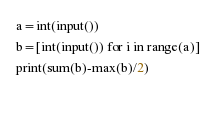<code> <loc_0><loc_0><loc_500><loc_500><_Python_>a=int(input())
b=[int(input()) for i in range(a)]
print(sum(b)-max(b)/2)
  </code> 